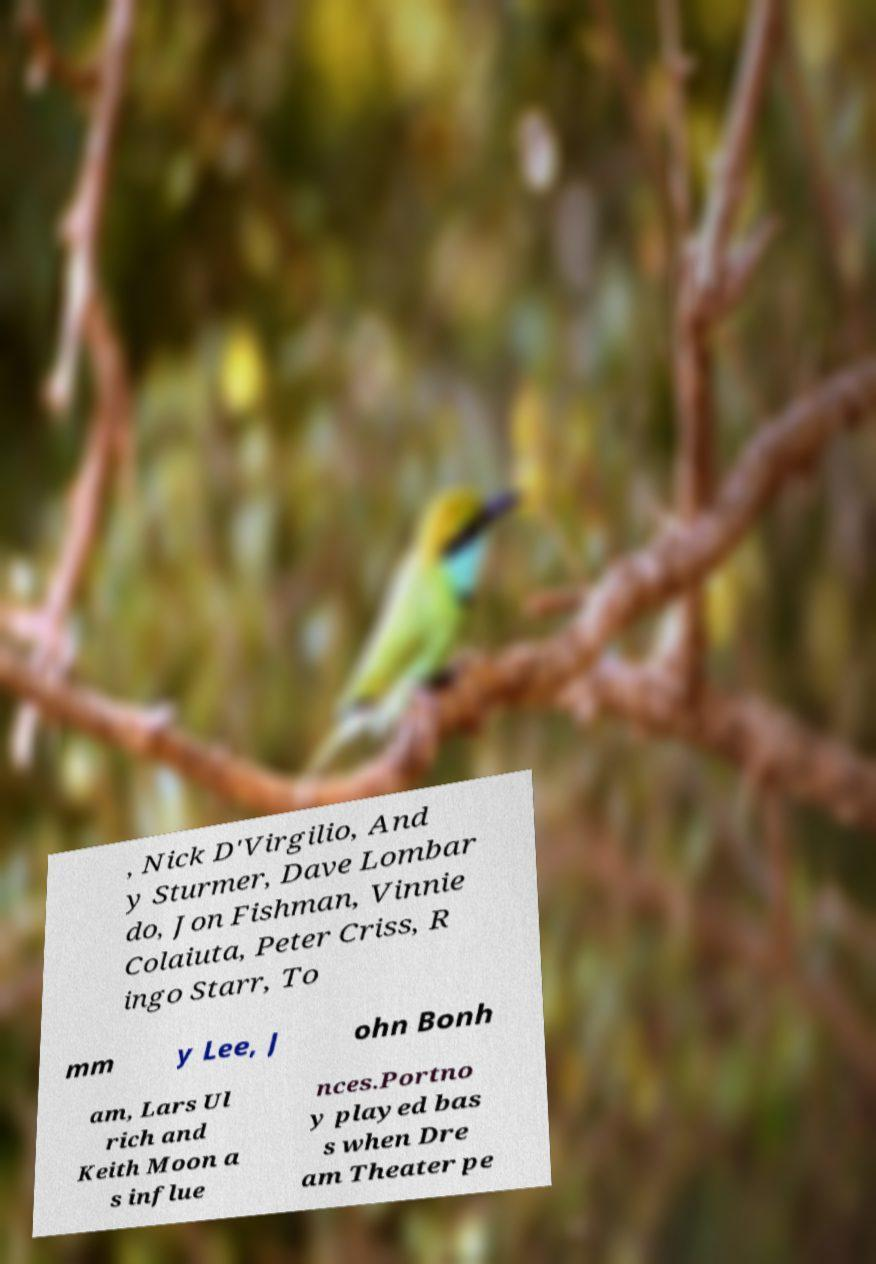I need the written content from this picture converted into text. Can you do that? , Nick D'Virgilio, And y Sturmer, Dave Lombar do, Jon Fishman, Vinnie Colaiuta, Peter Criss, R ingo Starr, To mm y Lee, J ohn Bonh am, Lars Ul rich and Keith Moon a s influe nces.Portno y played bas s when Dre am Theater pe 